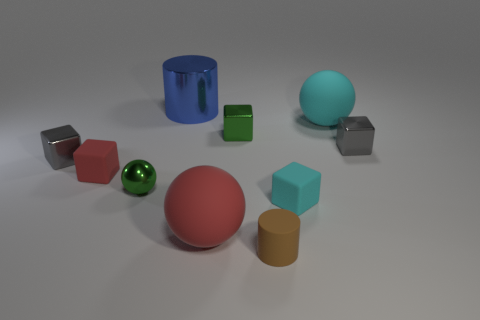Is the number of big things greater than the number of small brown things?
Give a very brief answer. Yes. How many tiny matte things are to the left of the tiny gray object that is to the left of the big shiny cylinder?
Make the answer very short. 0. What number of objects are cubes that are right of the green metal sphere or tiny gray blocks?
Your answer should be compact. 4. Is there a big red matte object of the same shape as the small cyan object?
Your answer should be very brief. No. There is a cyan matte thing in front of the tiny shiny thing that is to the right of the tiny green shiny cube; what shape is it?
Your response must be concise. Cube. How many blocks are either cyan things or red things?
Give a very brief answer. 2. There is a object that is the same color as the small sphere; what material is it?
Your answer should be very brief. Metal. There is a gray object to the left of the metal ball; is its shape the same as the tiny green thing that is to the right of the green sphere?
Keep it short and to the point. Yes. There is a matte object that is on the right side of the small red rubber thing and left of the tiny brown rubber cylinder; what is its color?
Offer a very short reply. Red. There is a big metal thing; is its color the same as the small matte cube that is to the right of the blue shiny cylinder?
Keep it short and to the point. No. 